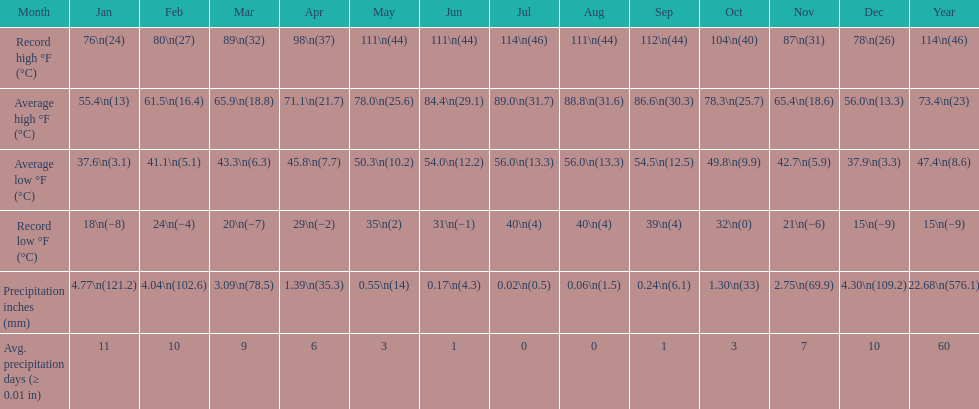How many months had a record high of 111 degrees? 3. 